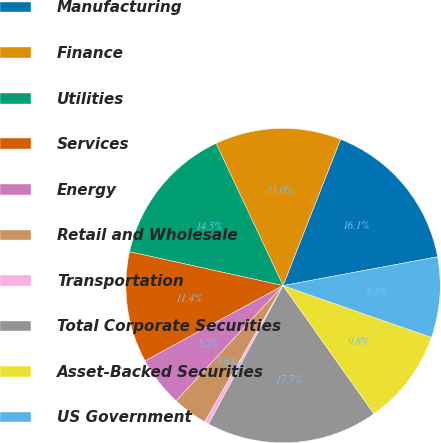Convert chart. <chart><loc_0><loc_0><loc_500><loc_500><pie_chart><fcel>Manufacturing<fcel>Finance<fcel>Utilities<fcel>Services<fcel>Energy<fcel>Retail and Wholesale<fcel>Transportation<fcel>Total Corporate Securities<fcel>Asset-Backed Securities<fcel>US Government<nl><fcel>16.1%<fcel>12.97%<fcel>14.54%<fcel>11.41%<fcel>5.15%<fcel>3.59%<fcel>0.46%<fcel>17.66%<fcel>9.84%<fcel>8.28%<nl></chart> 